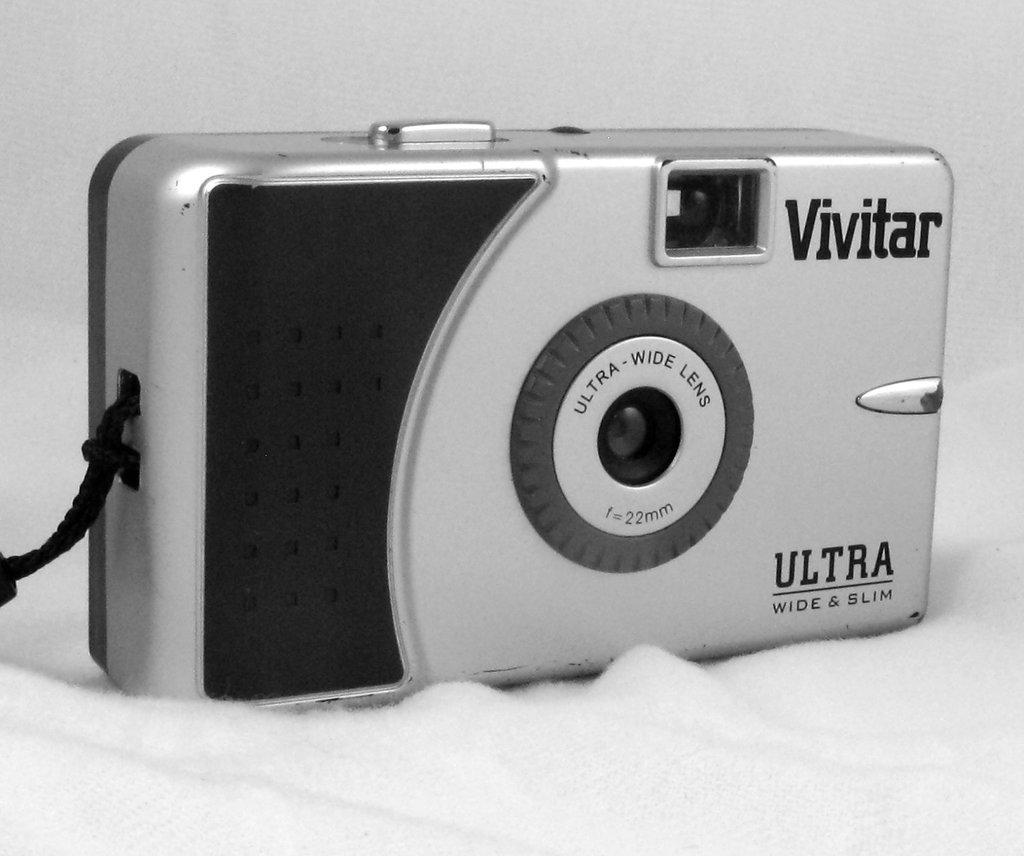What object is the main focus of the image? There is a camera in the image. Where is the camera placed? The camera is placed on a towel. What type of sponge is being used to clean the camera in the image? There is no sponge present in the image, and the camera is not being cleaned. 